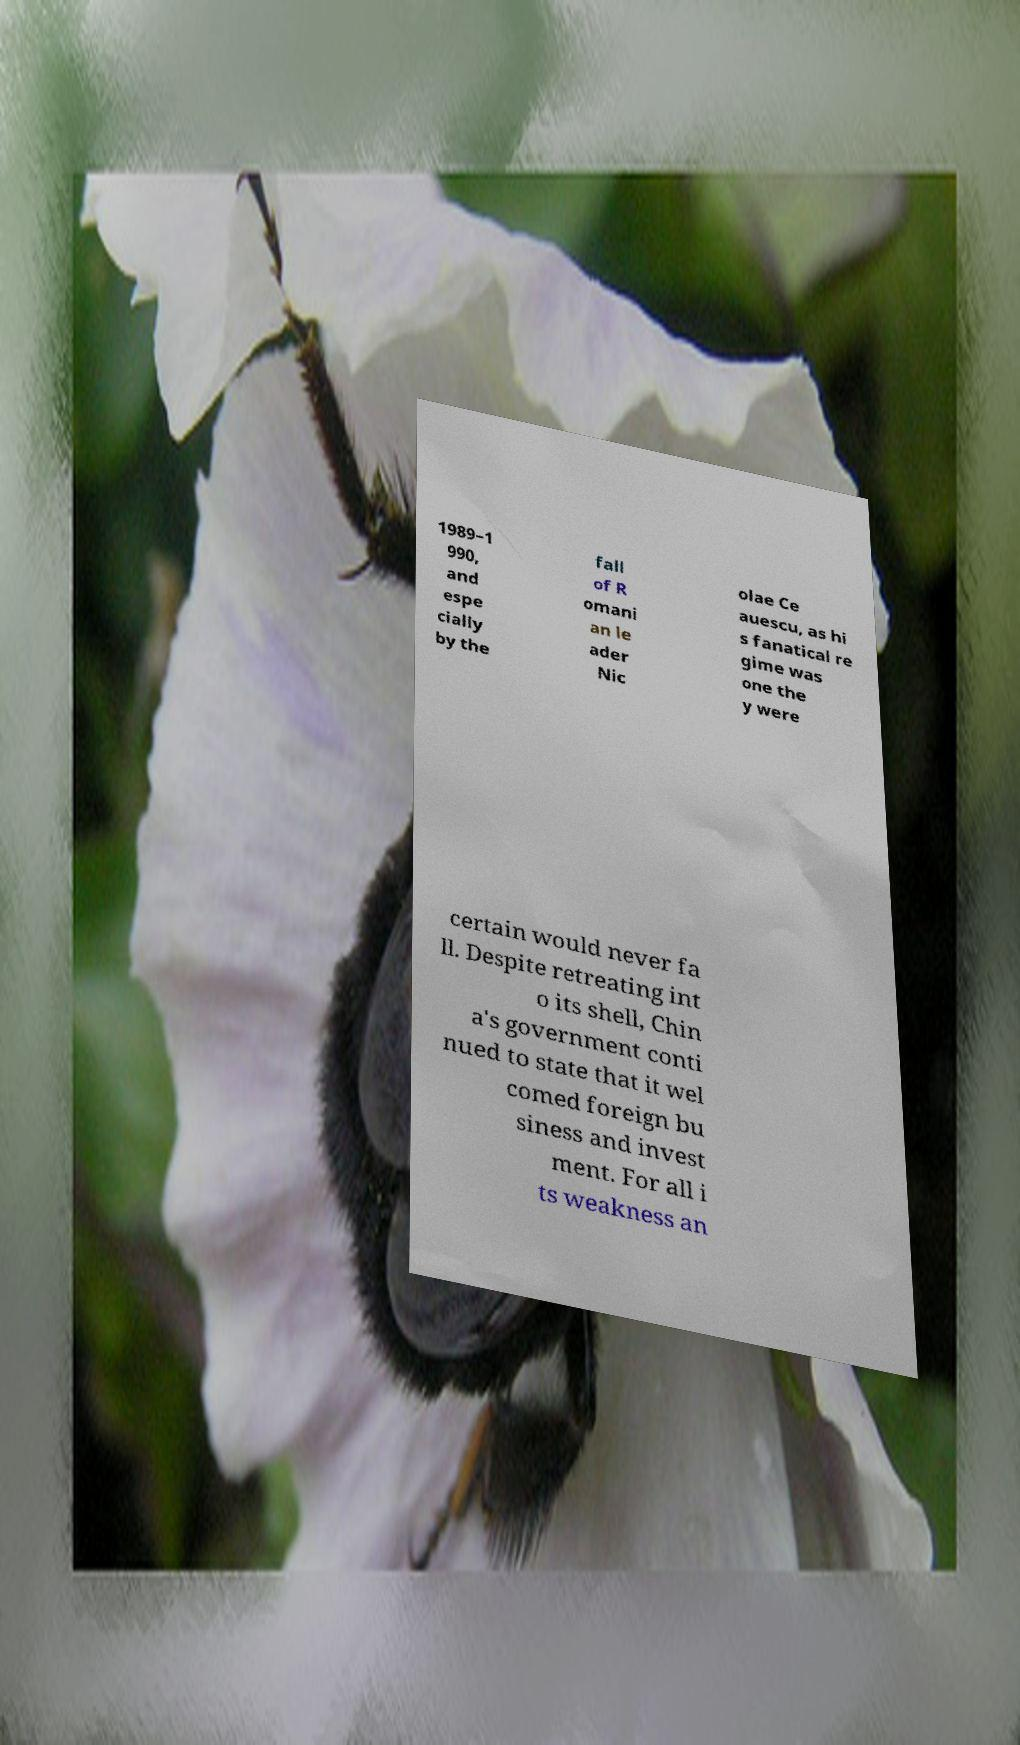For documentation purposes, I need the text within this image transcribed. Could you provide that? 1989–1 990, and espe cially by the fall of R omani an le ader Nic olae Ce auescu, as hi s fanatical re gime was one the y were certain would never fa ll. Despite retreating int o its shell, Chin a's government conti nued to state that it wel comed foreign bu siness and invest ment. For all i ts weakness an 